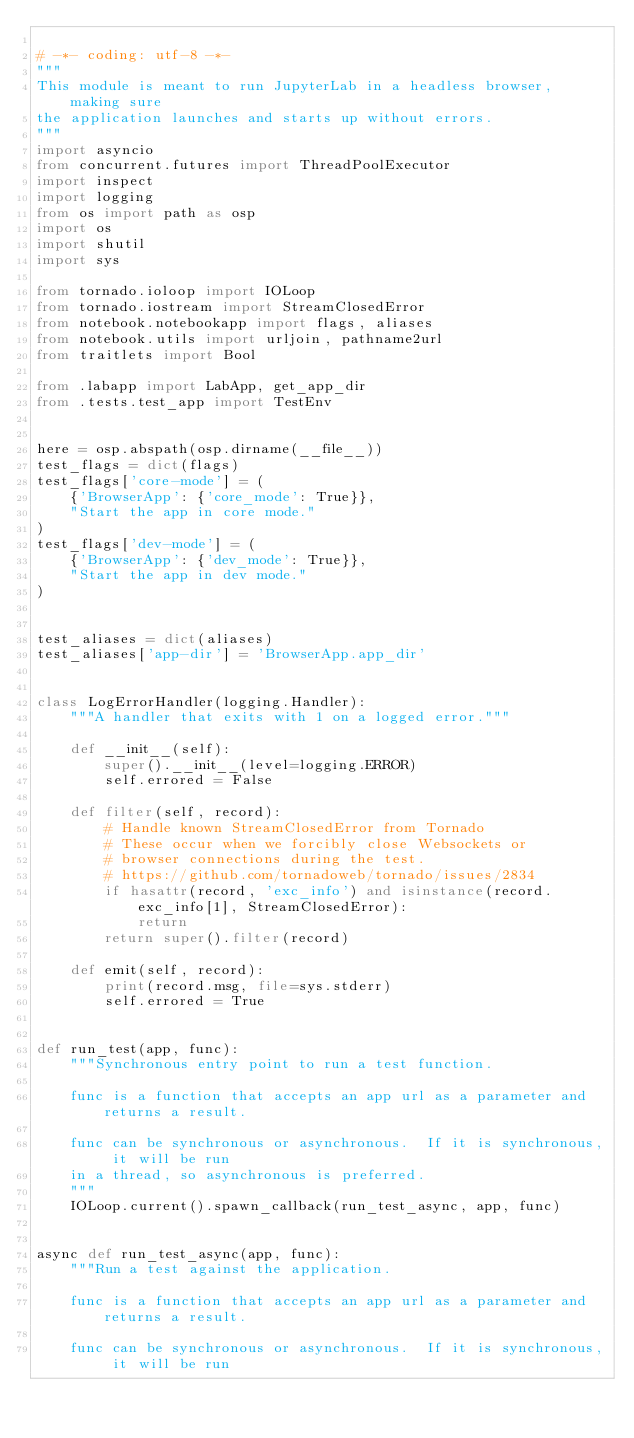<code> <loc_0><loc_0><loc_500><loc_500><_Python_>
# -*- coding: utf-8 -*-
"""
This module is meant to run JupyterLab in a headless browser, making sure
the application launches and starts up without errors.
"""
import asyncio
from concurrent.futures import ThreadPoolExecutor
import inspect
import logging
from os import path as osp
import os
import shutil
import sys

from tornado.ioloop import IOLoop
from tornado.iostream import StreamClosedError
from notebook.notebookapp import flags, aliases
from notebook.utils import urljoin, pathname2url
from traitlets import Bool

from .labapp import LabApp, get_app_dir
from .tests.test_app import TestEnv


here = osp.abspath(osp.dirname(__file__))
test_flags = dict(flags)
test_flags['core-mode'] = (
    {'BrowserApp': {'core_mode': True}},
    "Start the app in core mode."
)
test_flags['dev-mode'] = (
    {'BrowserApp': {'dev_mode': True}},
    "Start the app in dev mode."
)


test_aliases = dict(aliases)
test_aliases['app-dir'] = 'BrowserApp.app_dir'


class LogErrorHandler(logging.Handler):
    """A handler that exits with 1 on a logged error."""

    def __init__(self):
        super().__init__(level=logging.ERROR)
        self.errored = False

    def filter(self, record):
        # Handle known StreamClosedError from Tornado
        # These occur when we forcibly close Websockets or
        # browser connections during the test.
        # https://github.com/tornadoweb/tornado/issues/2834
        if hasattr(record, 'exc_info') and isinstance(record.exc_info[1], StreamClosedError):
            return
        return super().filter(record)

    def emit(self, record):
        print(record.msg, file=sys.stderr)
        self.errored = True


def run_test(app, func):
    """Synchronous entry point to run a test function.

    func is a function that accepts an app url as a parameter and returns a result.

    func can be synchronous or asynchronous.  If it is synchronous, it will be run
    in a thread, so asynchronous is preferred.
    """
    IOLoop.current().spawn_callback(run_test_async, app, func)


async def run_test_async(app, func):
    """Run a test against the application.

    func is a function that accepts an app url as a parameter and returns a result.

    func can be synchronous or asynchronous.  If it is synchronous, it will be run</code> 